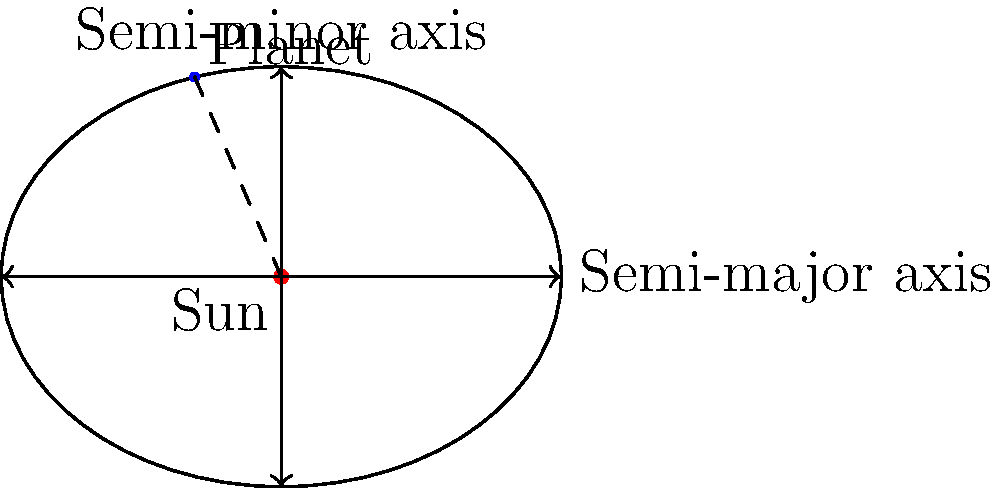In the elliptical orbit diagram, which point along the planet's path represents its closest approach to the Sun, and how does this relate to Kepler's laws of planetary motion? To answer this question, let's break it down step-by-step:

1. Elliptical orbits: The diagram shows a planet orbiting the Sun in an elliptical path, as described by Kepler's First Law of Planetary Motion.

2. Closest approach: The point of closest approach to the Sun in an elliptical orbit is called the perihelion. This occurs at one end of the ellipse's major axis, closest to the focal point where the Sun is located.

3. Kepler's Second Law: This law states that a line segment joining a planet and the Sun sweeps out equal areas during equal intervals of time. This means the planet moves fastest at perihelion and slowest at aphelion (farthest point from the Sun).

4. Identifying perihelion: In the diagram, the perihelion would be located at the point where the ellipse intersects the major axis on the side closest to the Sun.

5. Relation to orbital speed: At perihelion, the planet's orbital speed is at its maximum due to the increased gravitational influence of the Sun at close range.

6. Energy conservation: The total energy of the orbit (kinetic + potential) remains constant, as described by Kepler's Third Law. At perihelion, kinetic energy is highest and potential energy is lowest.

This concept challenges the common misconception in open-world games that planetary orbits are circular and uniform, highlighting the complexity and dynamism of real astronomical systems.
Answer: Perihelion 